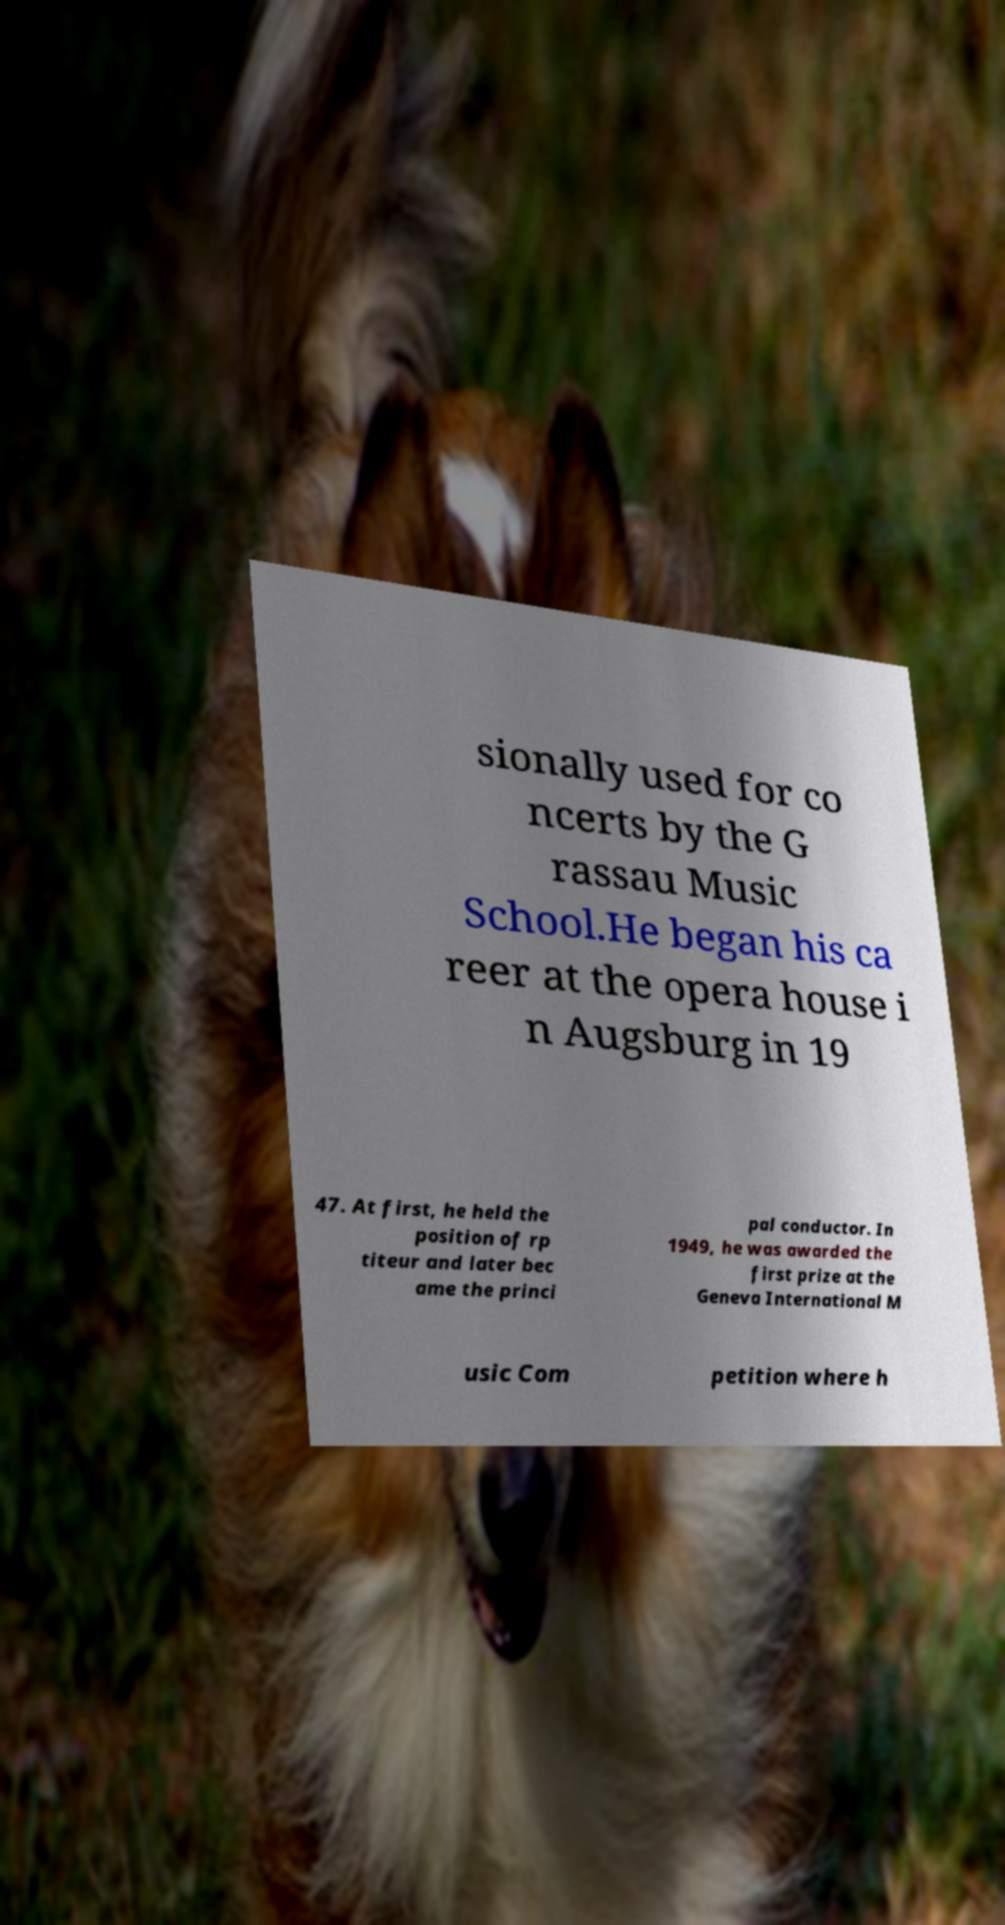There's text embedded in this image that I need extracted. Can you transcribe it verbatim? sionally used for co ncerts by the G rassau Music School.He began his ca reer at the opera house i n Augsburg in 19 47. At first, he held the position of rp titeur and later bec ame the princi pal conductor. In 1949, he was awarded the first prize at the Geneva International M usic Com petition where h 